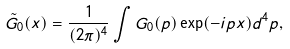<formula> <loc_0><loc_0><loc_500><loc_500>\tilde { G } _ { 0 } ( x ) = \frac { 1 } { ( 2 \pi ) ^ { 4 } } \int G _ { 0 } ( p ) \exp ( - i p x ) d ^ { 4 } p ,</formula> 